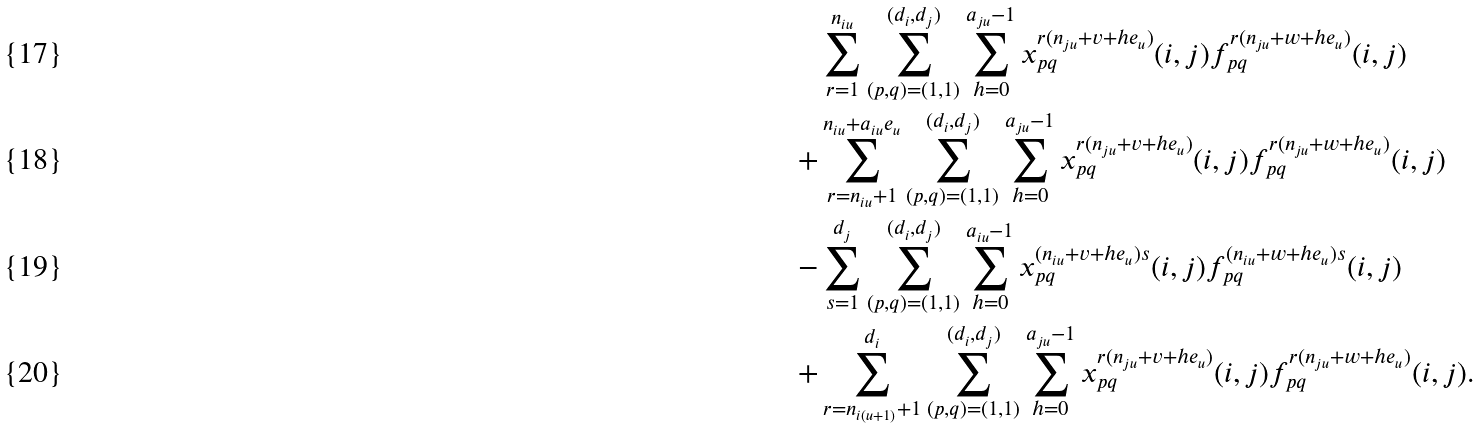<formula> <loc_0><loc_0><loc_500><loc_500>& \sum _ { r = 1 } ^ { n _ { i u } } \sum _ { ( p , q ) = ( 1 , 1 ) } ^ { ( d _ { i } , d _ { j } ) } \sum _ { h = 0 } ^ { a _ { j u } - 1 } x _ { p q } ^ { r ( n _ { j u } + v + h e _ { u } ) } ( i , j ) f _ { p q } ^ { r ( n _ { j u } + w + h e _ { u } ) } ( i , j ) \\ + & \sum _ { r = n _ { i u } + 1 } ^ { n _ { i u } + a _ { i u } e _ { u } } \sum _ { ( p , q ) = ( 1 , 1 ) } ^ { ( d _ { i } , d _ { j } ) } \sum _ { h = 0 } ^ { a _ { j u } - 1 } x _ { p q } ^ { r ( n _ { j u } + v + h e _ { u } ) } ( i , j ) f _ { p q } ^ { r ( n _ { j u } + w + h e _ { u } ) } ( i , j ) \\ - & \sum _ { s = 1 } ^ { d _ { j } } \sum _ { ( p , q ) = ( 1 , 1 ) } ^ { ( d _ { i } , d _ { j } ) } \sum _ { h = 0 } ^ { a _ { i u } - 1 } x _ { p q } ^ { ( n _ { i u } + v + h e _ { u } ) s } ( i , j ) f ^ { ( n _ { i u } + w + h e _ { u } ) s } _ { p q } ( i , j ) \\ + & \sum _ { r = n _ { i ( u + 1 ) } + 1 } ^ { d _ { i } } \sum _ { ( p , q ) = ( 1 , 1 ) } ^ { ( d _ { i } , d _ { j } ) } \sum _ { h = 0 } ^ { a _ { j u } - 1 } x _ { p q } ^ { r ( n _ { j u } + v + h e _ { u } ) } ( i , j ) f _ { p q } ^ { r ( n _ { j u } + w + h e _ { u } ) } ( i , j ) .</formula> 